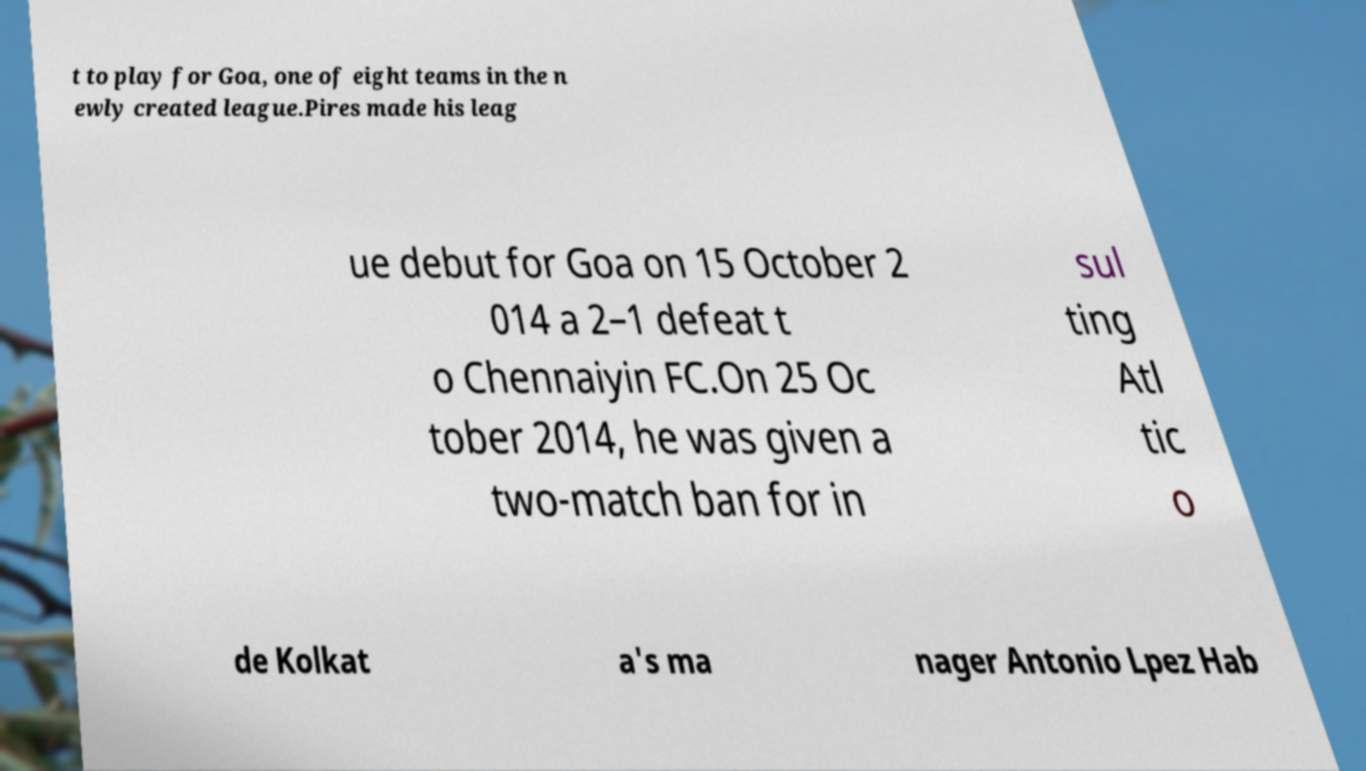For documentation purposes, I need the text within this image transcribed. Could you provide that? t to play for Goa, one of eight teams in the n ewly created league.Pires made his leag ue debut for Goa on 15 October 2 014 a 2–1 defeat t o Chennaiyin FC.On 25 Oc tober 2014, he was given a two-match ban for in sul ting Atl tic o de Kolkat a's ma nager Antonio Lpez Hab 